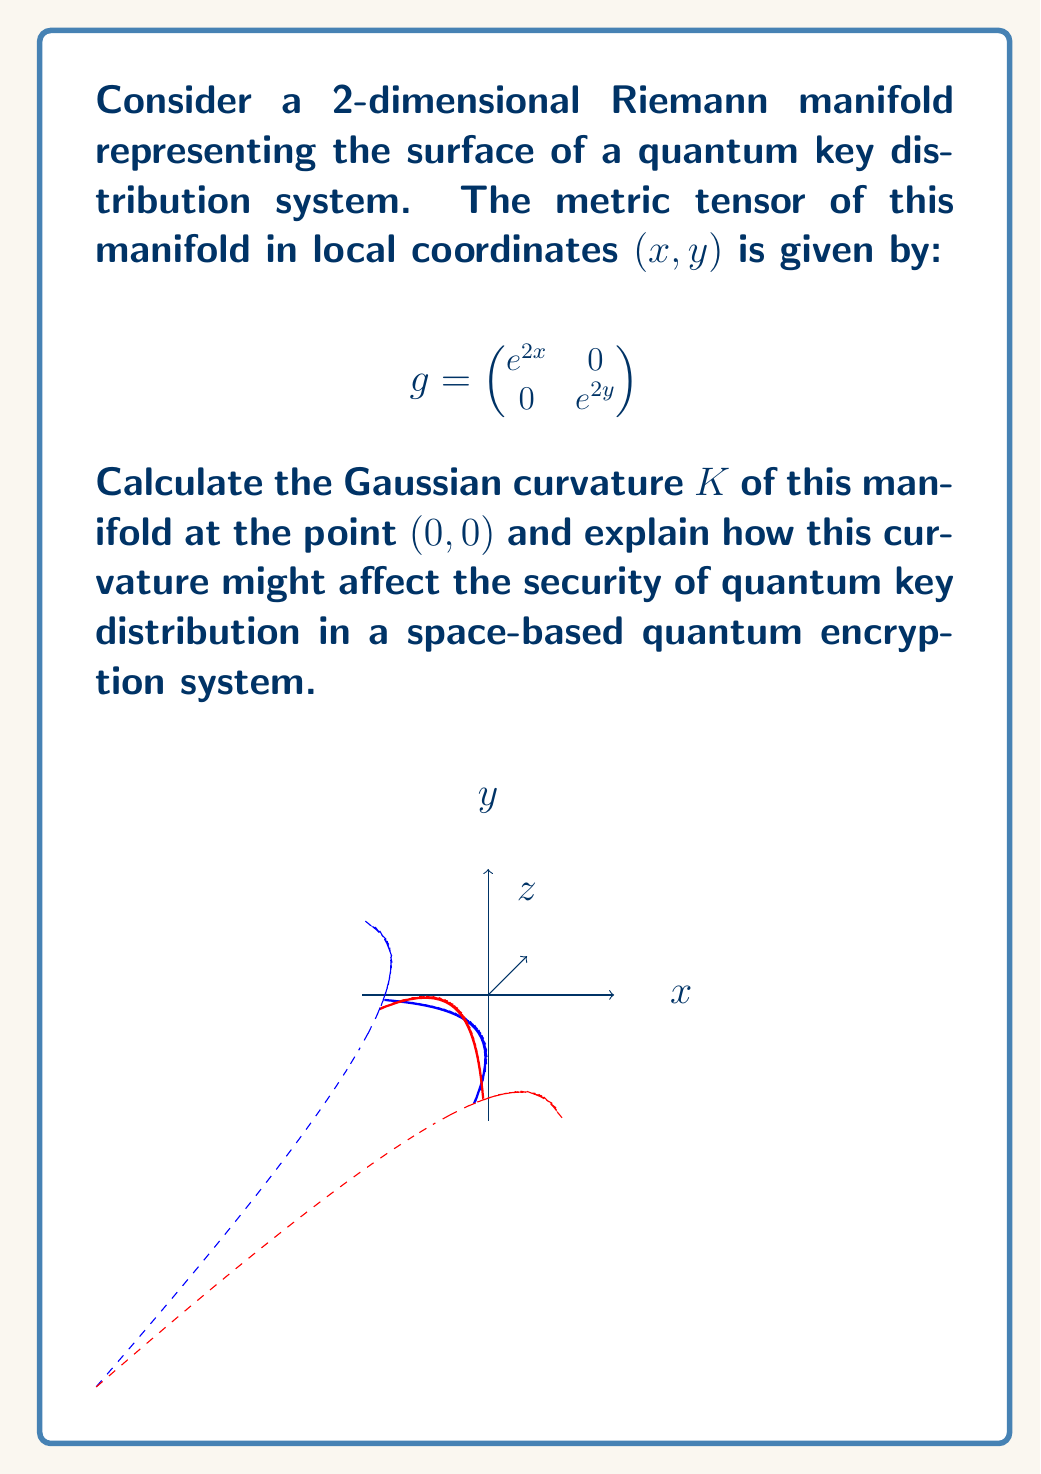Show me your answer to this math problem. To solve this problem, we'll follow these steps:

1) The Gaussian curvature $K$ of a 2D Riemann manifold is given by:

   $$K = \frac{R_{1212}}{g_{11}g_{22} - g_{12}^2}$$

   where $R_{1212}$ is a component of the Riemann curvature tensor.

2) To calculate $R_{1212}$, we need to first find the Christoffel symbols:

   $$\Gamma^k_{ij} = \frac{1}{2}g^{kl}(\partial_i g_{jl} + \partial_j g_{il} - \partial_l g_{ij})$$

3) For our metric, the non-zero Christoffel symbols are:

   $$\Gamma^1_{11} = 1, \Gamma^2_{22} = 1$$

4) Now we can calculate $R_{1212}$:

   $$R_{1212} = \partial_1 \Gamma^2_{12} - \partial_2 \Gamma^2_{11} + \Gamma^2_{1k}\Gamma^k_{12} - \Gamma^2_{2k}\Gamma^k_{11}$$

   $$R_{1212} = 0 - 0 + 0 - 0 = 0$$

5) Therefore, the Gaussian curvature is:

   $$K = \frac{R_{1212}}{g_{11}g_{22} - g_{12}^2} = \frac{0}{e^{2x}e^{2y} - 0} = 0$$

6) This zero curvature implies that the manifold is locally flat at $(0,0)$, which has implications for quantum key distribution:

   a) In a flat space, photons travel in straight lines, making it easier to predict their paths and maintain alignment in space-based systems.
   
   b) However, the lack of curvature might make the system more vulnerable to interception, as there are no gravitational lensing effects to naturally obscure or deflect signals.
   
   c) The flat space simplifies calculations for quantum state preservation, potentially allowing for more efficient key distribution protocols.
   
   d) On the other hand, the absence of curvature eliminates potential quantum encryption schemes that could leverage gravitational effects for additional security.
Answer: $K = 0$ (flat at (0,0)); simplifies quantum key distribution but may reduce natural protection against interception. 